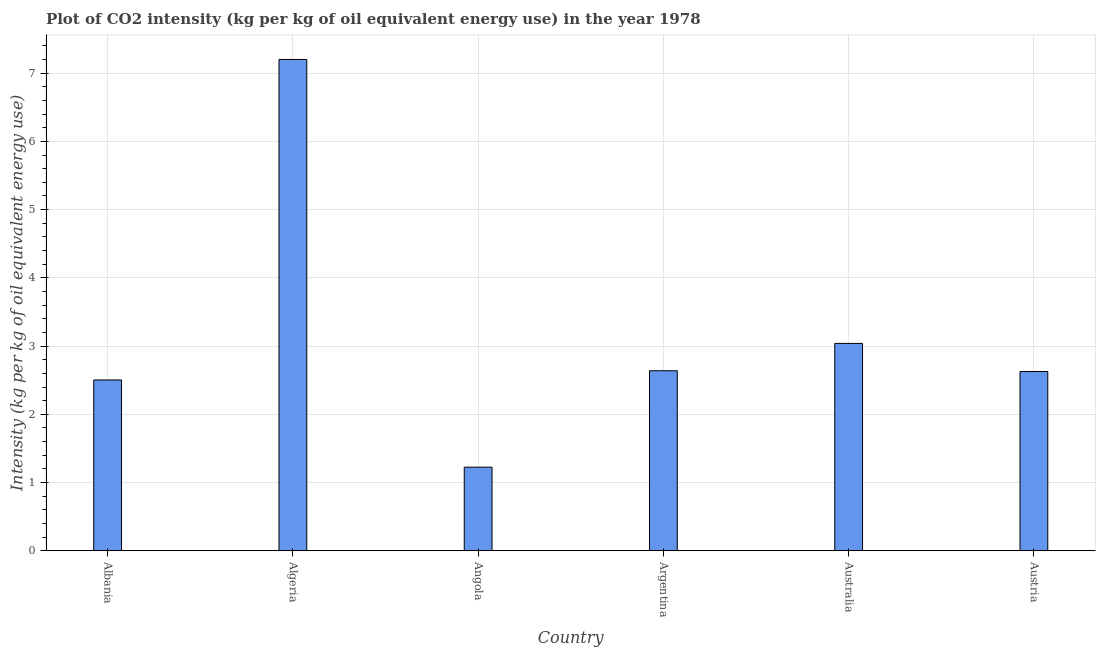Does the graph contain grids?
Provide a succinct answer. Yes. What is the title of the graph?
Make the answer very short. Plot of CO2 intensity (kg per kg of oil equivalent energy use) in the year 1978. What is the label or title of the Y-axis?
Give a very brief answer. Intensity (kg per kg of oil equivalent energy use). What is the co2 intensity in Australia?
Your answer should be compact. 3.04. Across all countries, what is the maximum co2 intensity?
Your answer should be compact. 7.2. Across all countries, what is the minimum co2 intensity?
Offer a terse response. 1.23. In which country was the co2 intensity maximum?
Your answer should be compact. Algeria. In which country was the co2 intensity minimum?
Your response must be concise. Angola. What is the sum of the co2 intensity?
Offer a very short reply. 19.24. What is the difference between the co2 intensity in Albania and Australia?
Give a very brief answer. -0.54. What is the average co2 intensity per country?
Provide a short and direct response. 3.21. What is the median co2 intensity?
Keep it short and to the point. 2.63. What is the ratio of the co2 intensity in Albania to that in Austria?
Offer a terse response. 0.95. Is the difference between the co2 intensity in Angola and Austria greater than the difference between any two countries?
Your answer should be compact. No. What is the difference between the highest and the second highest co2 intensity?
Offer a very short reply. 4.16. Is the sum of the co2 intensity in Algeria and Argentina greater than the maximum co2 intensity across all countries?
Your answer should be compact. Yes. What is the difference between the highest and the lowest co2 intensity?
Keep it short and to the point. 5.98. Are all the bars in the graph horizontal?
Give a very brief answer. No. What is the Intensity (kg per kg of oil equivalent energy use) of Albania?
Offer a terse response. 2.5. What is the Intensity (kg per kg of oil equivalent energy use) in Algeria?
Your response must be concise. 7.2. What is the Intensity (kg per kg of oil equivalent energy use) of Angola?
Offer a terse response. 1.23. What is the Intensity (kg per kg of oil equivalent energy use) in Argentina?
Your answer should be very brief. 2.64. What is the Intensity (kg per kg of oil equivalent energy use) of Australia?
Provide a succinct answer. 3.04. What is the Intensity (kg per kg of oil equivalent energy use) of Austria?
Keep it short and to the point. 2.63. What is the difference between the Intensity (kg per kg of oil equivalent energy use) in Albania and Algeria?
Your answer should be compact. -4.7. What is the difference between the Intensity (kg per kg of oil equivalent energy use) in Albania and Angola?
Make the answer very short. 1.28. What is the difference between the Intensity (kg per kg of oil equivalent energy use) in Albania and Argentina?
Make the answer very short. -0.13. What is the difference between the Intensity (kg per kg of oil equivalent energy use) in Albania and Australia?
Offer a very short reply. -0.54. What is the difference between the Intensity (kg per kg of oil equivalent energy use) in Albania and Austria?
Your answer should be very brief. -0.12. What is the difference between the Intensity (kg per kg of oil equivalent energy use) in Algeria and Angola?
Your answer should be compact. 5.98. What is the difference between the Intensity (kg per kg of oil equivalent energy use) in Algeria and Argentina?
Offer a very short reply. 4.56. What is the difference between the Intensity (kg per kg of oil equivalent energy use) in Algeria and Australia?
Offer a very short reply. 4.16. What is the difference between the Intensity (kg per kg of oil equivalent energy use) in Algeria and Austria?
Make the answer very short. 4.57. What is the difference between the Intensity (kg per kg of oil equivalent energy use) in Angola and Argentina?
Provide a succinct answer. -1.41. What is the difference between the Intensity (kg per kg of oil equivalent energy use) in Angola and Australia?
Offer a very short reply. -1.81. What is the difference between the Intensity (kg per kg of oil equivalent energy use) in Angola and Austria?
Provide a short and direct response. -1.4. What is the difference between the Intensity (kg per kg of oil equivalent energy use) in Argentina and Australia?
Give a very brief answer. -0.4. What is the difference between the Intensity (kg per kg of oil equivalent energy use) in Argentina and Austria?
Ensure brevity in your answer.  0.01. What is the difference between the Intensity (kg per kg of oil equivalent energy use) in Australia and Austria?
Ensure brevity in your answer.  0.41. What is the ratio of the Intensity (kg per kg of oil equivalent energy use) in Albania to that in Algeria?
Offer a terse response. 0.35. What is the ratio of the Intensity (kg per kg of oil equivalent energy use) in Albania to that in Angola?
Offer a terse response. 2.04. What is the ratio of the Intensity (kg per kg of oil equivalent energy use) in Albania to that in Argentina?
Your answer should be compact. 0.95. What is the ratio of the Intensity (kg per kg of oil equivalent energy use) in Albania to that in Australia?
Make the answer very short. 0.82. What is the ratio of the Intensity (kg per kg of oil equivalent energy use) in Albania to that in Austria?
Your response must be concise. 0.95. What is the ratio of the Intensity (kg per kg of oil equivalent energy use) in Algeria to that in Angola?
Offer a very short reply. 5.88. What is the ratio of the Intensity (kg per kg of oil equivalent energy use) in Algeria to that in Argentina?
Provide a short and direct response. 2.73. What is the ratio of the Intensity (kg per kg of oil equivalent energy use) in Algeria to that in Australia?
Keep it short and to the point. 2.37. What is the ratio of the Intensity (kg per kg of oil equivalent energy use) in Algeria to that in Austria?
Offer a terse response. 2.74. What is the ratio of the Intensity (kg per kg of oil equivalent energy use) in Angola to that in Argentina?
Ensure brevity in your answer.  0.46. What is the ratio of the Intensity (kg per kg of oil equivalent energy use) in Angola to that in Australia?
Your answer should be very brief. 0.4. What is the ratio of the Intensity (kg per kg of oil equivalent energy use) in Angola to that in Austria?
Your answer should be very brief. 0.47. What is the ratio of the Intensity (kg per kg of oil equivalent energy use) in Argentina to that in Australia?
Give a very brief answer. 0.87. What is the ratio of the Intensity (kg per kg of oil equivalent energy use) in Australia to that in Austria?
Provide a succinct answer. 1.16. 